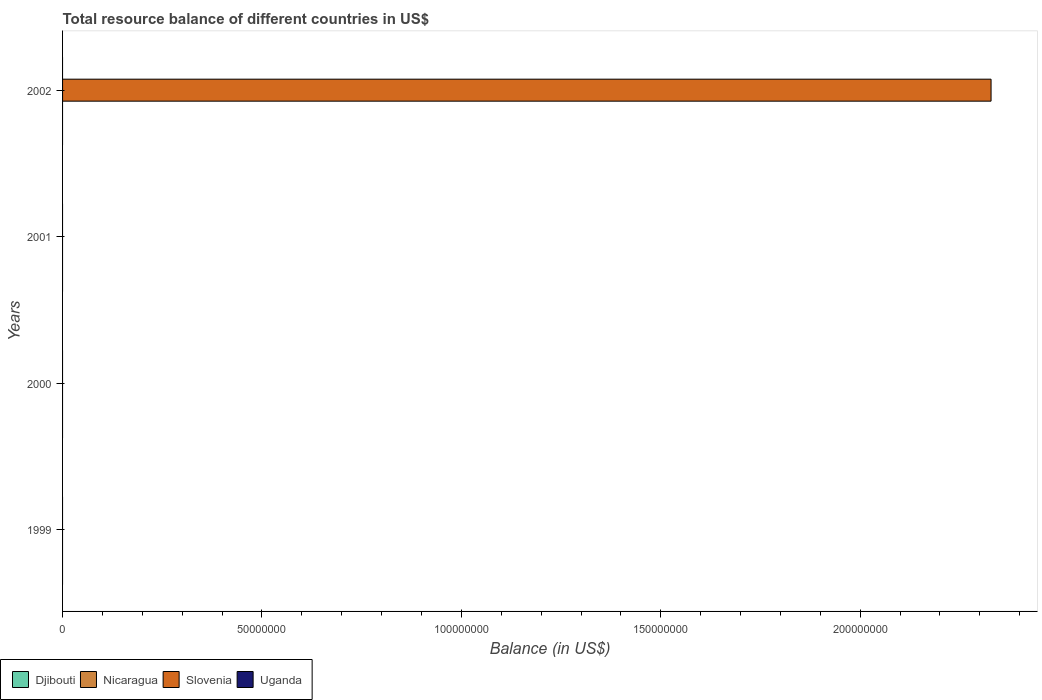How many different coloured bars are there?
Offer a terse response. 1. Are the number of bars on each tick of the Y-axis equal?
Provide a succinct answer. No. What is the label of the 1st group of bars from the top?
Provide a short and direct response. 2002. In how many cases, is the number of bars for a given year not equal to the number of legend labels?
Provide a succinct answer. 4. What is the average total resource balance in Slovenia per year?
Keep it short and to the point. 5.82e+07. In how many years, is the total resource balance in Slovenia greater than 200000000 US$?
Keep it short and to the point. 1. What is the difference between the highest and the lowest total resource balance in Slovenia?
Your response must be concise. 2.33e+08. Is it the case that in every year, the sum of the total resource balance in Uganda and total resource balance in Djibouti is greater than the sum of total resource balance in Slovenia and total resource balance in Nicaragua?
Your response must be concise. No. Is it the case that in every year, the sum of the total resource balance in Slovenia and total resource balance in Nicaragua is greater than the total resource balance in Djibouti?
Your answer should be compact. No. How many bars are there?
Offer a terse response. 1. Are all the bars in the graph horizontal?
Ensure brevity in your answer.  Yes. How many years are there in the graph?
Your answer should be compact. 4. Does the graph contain any zero values?
Make the answer very short. Yes. Does the graph contain grids?
Provide a short and direct response. No. Where does the legend appear in the graph?
Provide a succinct answer. Bottom left. How many legend labels are there?
Ensure brevity in your answer.  4. What is the title of the graph?
Your answer should be compact. Total resource balance of different countries in US$. What is the label or title of the X-axis?
Offer a very short reply. Balance (in US$). What is the label or title of the Y-axis?
Ensure brevity in your answer.  Years. What is the Balance (in US$) in Djibouti in 1999?
Offer a very short reply. 0. What is the Balance (in US$) in Nicaragua in 1999?
Offer a very short reply. 0. What is the Balance (in US$) in Nicaragua in 2000?
Offer a terse response. 0. What is the Balance (in US$) of Slovenia in 2000?
Provide a short and direct response. 0. What is the Balance (in US$) of Uganda in 2000?
Your answer should be very brief. 0. What is the Balance (in US$) in Nicaragua in 2001?
Your response must be concise. 0. What is the Balance (in US$) of Uganda in 2001?
Ensure brevity in your answer.  0. What is the Balance (in US$) in Slovenia in 2002?
Keep it short and to the point. 2.33e+08. What is the Balance (in US$) of Uganda in 2002?
Give a very brief answer. 0. Across all years, what is the maximum Balance (in US$) of Slovenia?
Make the answer very short. 2.33e+08. Across all years, what is the minimum Balance (in US$) of Slovenia?
Your response must be concise. 0. What is the total Balance (in US$) of Slovenia in the graph?
Provide a short and direct response. 2.33e+08. What is the total Balance (in US$) in Uganda in the graph?
Keep it short and to the point. 0. What is the average Balance (in US$) in Djibouti per year?
Your answer should be very brief. 0. What is the average Balance (in US$) in Nicaragua per year?
Offer a terse response. 0. What is the average Balance (in US$) of Slovenia per year?
Make the answer very short. 5.82e+07. What is the average Balance (in US$) in Uganda per year?
Provide a short and direct response. 0. What is the difference between the highest and the lowest Balance (in US$) in Slovenia?
Your answer should be very brief. 2.33e+08. 